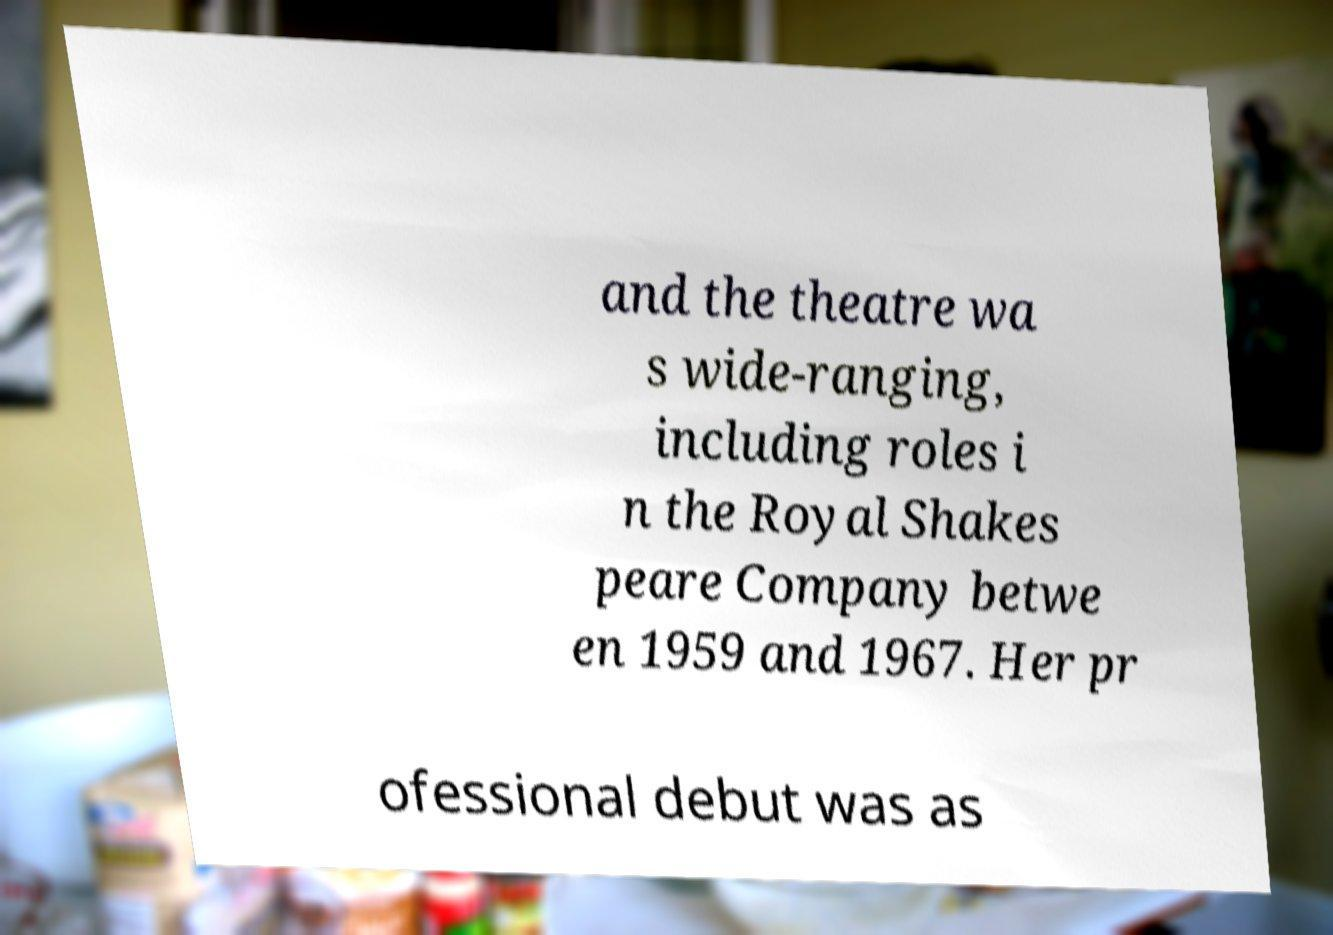Can you read and provide the text displayed in the image?This photo seems to have some interesting text. Can you extract and type it out for me? and the theatre wa s wide-ranging, including roles i n the Royal Shakes peare Company betwe en 1959 and 1967. Her pr ofessional debut was as 